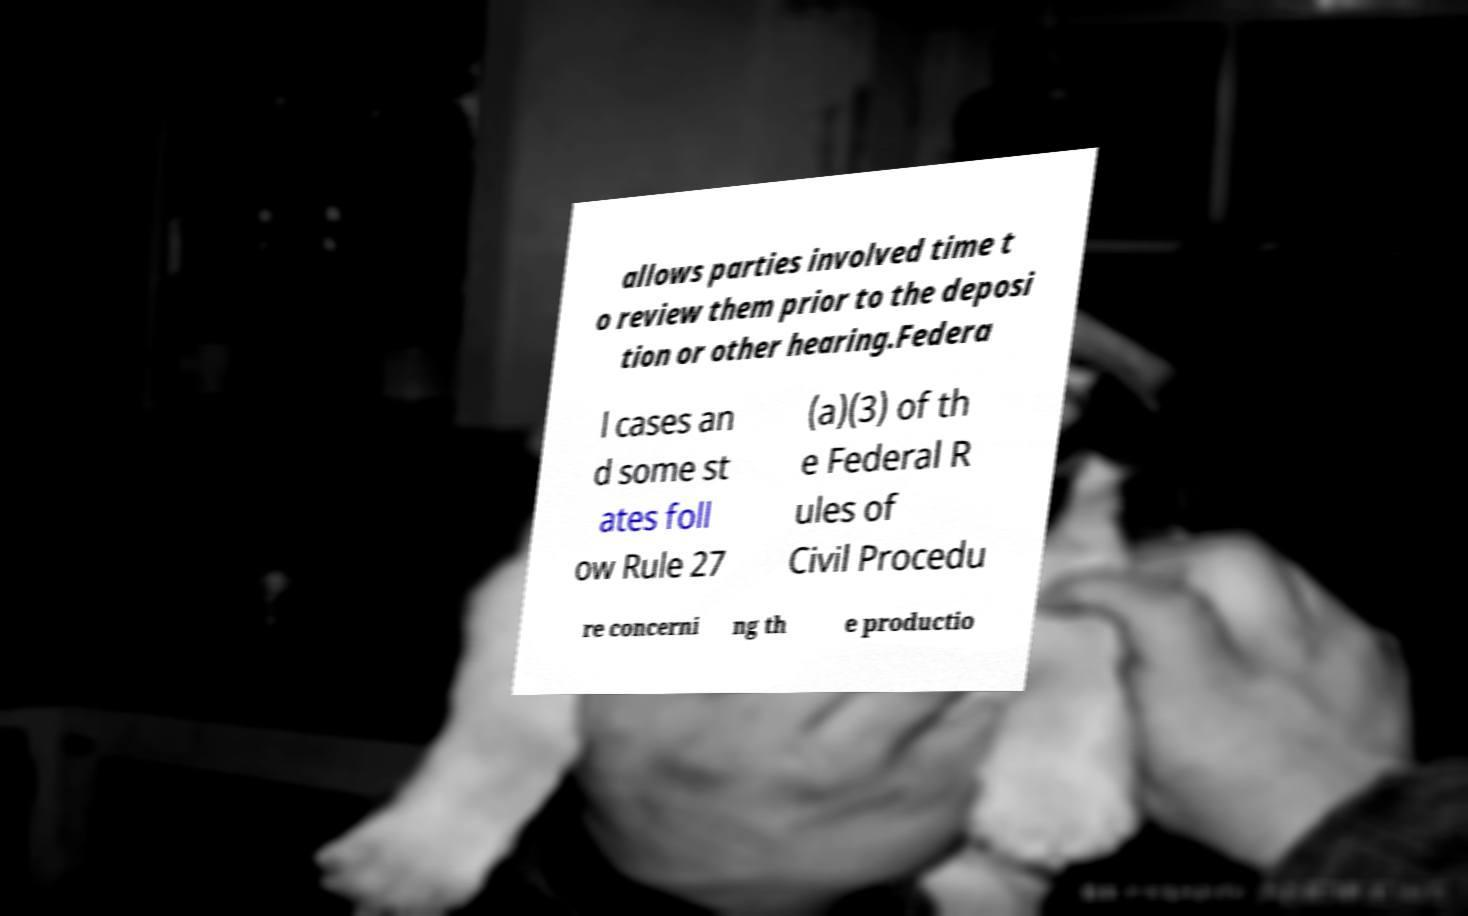Could you assist in decoding the text presented in this image and type it out clearly? allows parties involved time t o review them prior to the deposi tion or other hearing.Federa l cases an d some st ates foll ow Rule 27 (a)(3) of th e Federal R ules of Civil Procedu re concerni ng th e productio 